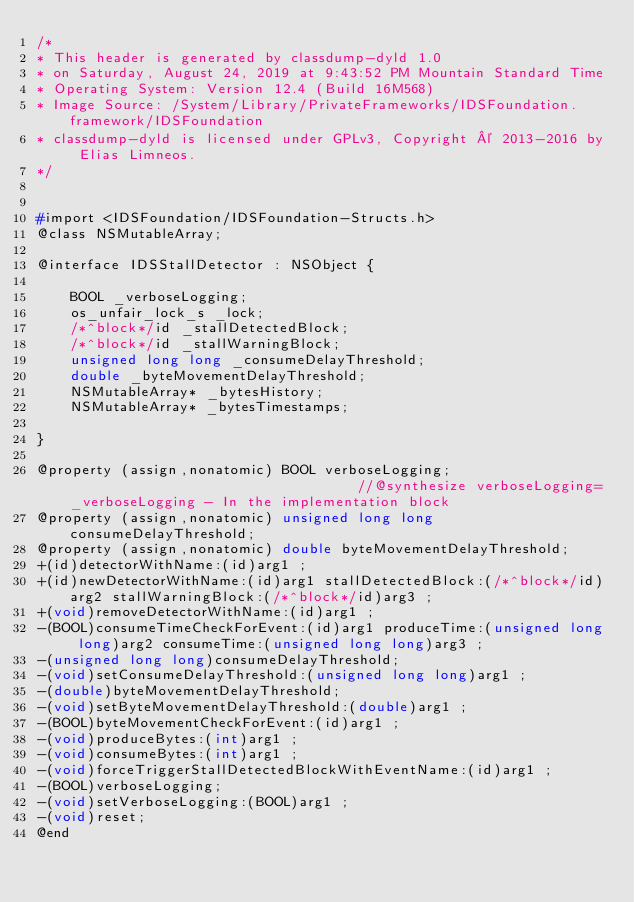<code> <loc_0><loc_0><loc_500><loc_500><_C_>/*
* This header is generated by classdump-dyld 1.0
* on Saturday, August 24, 2019 at 9:43:52 PM Mountain Standard Time
* Operating System: Version 12.4 (Build 16M568)
* Image Source: /System/Library/PrivateFrameworks/IDSFoundation.framework/IDSFoundation
* classdump-dyld is licensed under GPLv3, Copyright © 2013-2016 by Elias Limneos.
*/


#import <IDSFoundation/IDSFoundation-Structs.h>
@class NSMutableArray;

@interface IDSStallDetector : NSObject {

	BOOL _verboseLogging;
	os_unfair_lock_s _lock;
	/*^block*/id _stallDetectedBlock;
	/*^block*/id _stallWarningBlock;
	unsigned long long _consumeDelayThreshold;
	double _byteMovementDelayThreshold;
	NSMutableArray* _bytesHistory;
	NSMutableArray* _bytesTimestamps;

}

@property (assign,nonatomic) BOOL verboseLogging;                                   //@synthesize verboseLogging=_verboseLogging - In the implementation block
@property (assign,nonatomic) unsigned long long consumeDelayThreshold; 
@property (assign,nonatomic) double byteMovementDelayThreshold; 
+(id)detectorWithName:(id)arg1 ;
+(id)newDetectorWithName:(id)arg1 stallDetectedBlock:(/*^block*/id)arg2 stallWarningBlock:(/*^block*/id)arg3 ;
+(void)removeDetectorWithName:(id)arg1 ;
-(BOOL)consumeTimeCheckForEvent:(id)arg1 produceTime:(unsigned long long)arg2 consumeTime:(unsigned long long)arg3 ;
-(unsigned long long)consumeDelayThreshold;
-(void)setConsumeDelayThreshold:(unsigned long long)arg1 ;
-(double)byteMovementDelayThreshold;
-(void)setByteMovementDelayThreshold:(double)arg1 ;
-(BOOL)byteMovementCheckForEvent:(id)arg1 ;
-(void)produceBytes:(int)arg1 ;
-(void)consumeBytes:(int)arg1 ;
-(void)forceTriggerStallDetectedBlockWithEventName:(id)arg1 ;
-(BOOL)verboseLogging;
-(void)setVerboseLogging:(BOOL)arg1 ;
-(void)reset;
@end

</code> 